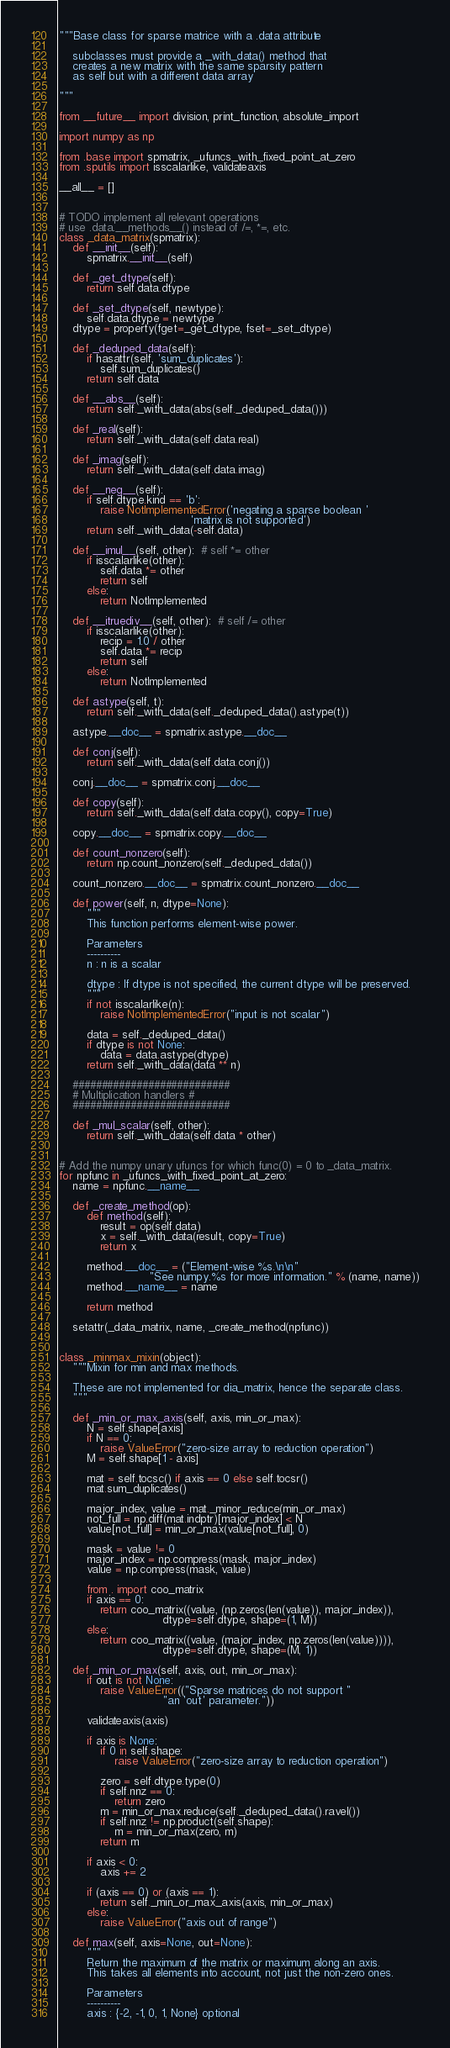Convert code to text. <code><loc_0><loc_0><loc_500><loc_500><_Python_>"""Base class for sparse matrice with a .data attribute

    subclasses must provide a _with_data() method that
    creates a new matrix with the same sparsity pattern
    as self but with a different data array

"""

from __future__ import division, print_function, absolute_import

import numpy as np

from .base import spmatrix, _ufuncs_with_fixed_point_at_zero
from .sputils import isscalarlike, validateaxis

__all__ = []


# TODO implement all relevant operations
# use .data.__methods__() instead of /=, *=, etc.
class _data_matrix(spmatrix):
    def __init__(self):
        spmatrix.__init__(self)

    def _get_dtype(self):
        return self.data.dtype

    def _set_dtype(self, newtype):
        self.data.dtype = newtype
    dtype = property(fget=_get_dtype, fset=_set_dtype)

    def _deduped_data(self):
        if hasattr(self, 'sum_duplicates'):
            self.sum_duplicates()
        return self.data

    def __abs__(self):
        return self._with_data(abs(self._deduped_data()))

    def _real(self):
        return self._with_data(self.data.real)

    def _imag(self):
        return self._with_data(self.data.imag)

    def __neg__(self):
        if self.dtype.kind == 'b':
            raise NotImplementedError('negating a sparse boolean '
                                      'matrix is not supported')
        return self._with_data(-self.data)

    def __imul__(self, other):  # self *= other
        if isscalarlike(other):
            self.data *= other
            return self
        else:
            return NotImplemented

    def __itruediv__(self, other):  # self /= other
        if isscalarlike(other):
            recip = 1.0 / other
            self.data *= recip
            return self
        else:
            return NotImplemented

    def astype(self, t):
        return self._with_data(self._deduped_data().astype(t))

    astype.__doc__ = spmatrix.astype.__doc__

    def conj(self):
        return self._with_data(self.data.conj())

    conj.__doc__ = spmatrix.conj.__doc__

    def copy(self):
        return self._with_data(self.data.copy(), copy=True)

    copy.__doc__ = spmatrix.copy.__doc__

    def count_nonzero(self):
        return np.count_nonzero(self._deduped_data())

    count_nonzero.__doc__ = spmatrix.count_nonzero.__doc__

    def power(self, n, dtype=None):
        """
        This function performs element-wise power.

        Parameters
        ----------
        n : n is a scalar

        dtype : If dtype is not specified, the current dtype will be preserved.
        """
        if not isscalarlike(n):
            raise NotImplementedError("input is not scalar")

        data = self._deduped_data()
        if dtype is not None:
            data = data.astype(dtype)
        return self._with_data(data ** n)

    ###########################
    # Multiplication handlers #
    ###########################

    def _mul_scalar(self, other):
        return self._with_data(self.data * other)


# Add the numpy unary ufuncs for which func(0) = 0 to _data_matrix.
for npfunc in _ufuncs_with_fixed_point_at_zero:
    name = npfunc.__name__

    def _create_method(op):
        def method(self):
            result = op(self.data)
            x = self._with_data(result, copy=True)
            return x

        method.__doc__ = ("Element-wise %s.\n\n"
                          "See numpy.%s for more information." % (name, name))
        method.__name__ = name

        return method

    setattr(_data_matrix, name, _create_method(npfunc))


class _minmax_mixin(object):
    """Mixin for min and max methods.

    These are not implemented for dia_matrix, hence the separate class.
    """

    def _min_or_max_axis(self, axis, min_or_max):
        N = self.shape[axis]
        if N == 0:
            raise ValueError("zero-size array to reduction operation")
        M = self.shape[1 - axis]

        mat = self.tocsc() if axis == 0 else self.tocsr()
        mat.sum_duplicates()

        major_index, value = mat._minor_reduce(min_or_max)
        not_full = np.diff(mat.indptr)[major_index] < N
        value[not_full] = min_or_max(value[not_full], 0)

        mask = value != 0
        major_index = np.compress(mask, major_index)
        value = np.compress(mask, value)

        from . import coo_matrix
        if axis == 0:
            return coo_matrix((value, (np.zeros(len(value)), major_index)),
                              dtype=self.dtype, shape=(1, M))
        else:
            return coo_matrix((value, (major_index, np.zeros(len(value)))),
                              dtype=self.dtype, shape=(M, 1))

    def _min_or_max(self, axis, out, min_or_max):
        if out is not None:
            raise ValueError(("Sparse matrices do not support "
                              "an 'out' parameter."))

        validateaxis(axis)

        if axis is None:
            if 0 in self.shape:
                raise ValueError("zero-size array to reduction operation")

            zero = self.dtype.type(0)
            if self.nnz == 0:
                return zero
            m = min_or_max.reduce(self._deduped_data().ravel())
            if self.nnz != np.product(self.shape):
                m = min_or_max(zero, m)
            return m

        if axis < 0:
            axis += 2

        if (axis == 0) or (axis == 1):
            return self._min_or_max_axis(axis, min_or_max)
        else:
            raise ValueError("axis out of range")

    def max(self, axis=None, out=None):
        """
        Return the maximum of the matrix or maximum along an axis.
        This takes all elements into account, not just the non-zero ones.

        Parameters
        ----------
        axis : {-2, -1, 0, 1, None} optional</code> 